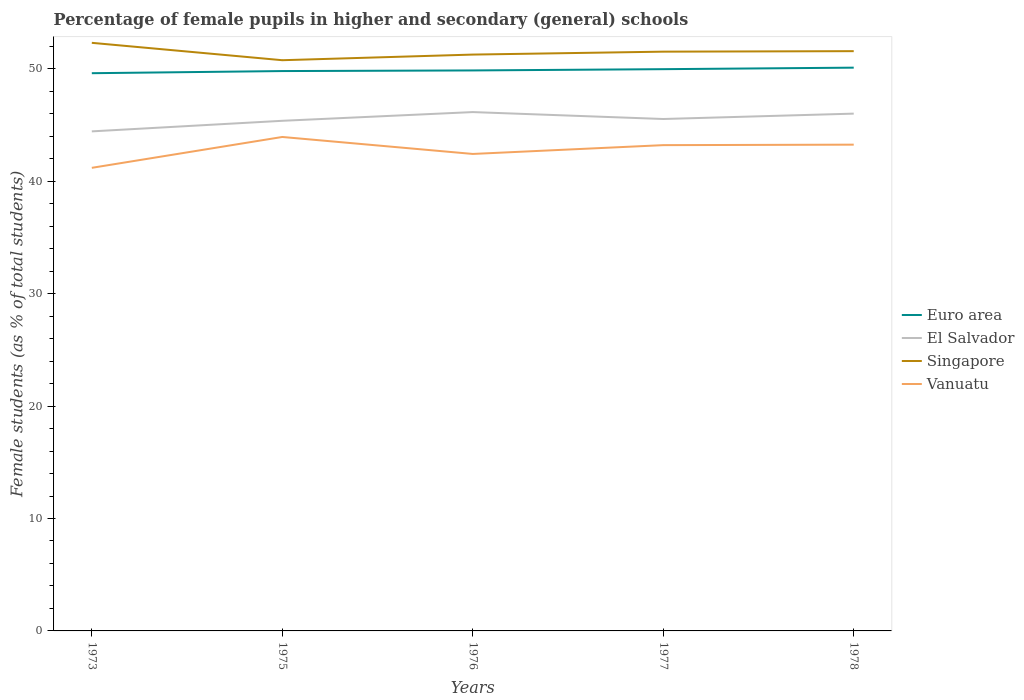How many different coloured lines are there?
Offer a terse response. 4. Does the line corresponding to Euro area intersect with the line corresponding to Vanuatu?
Provide a succinct answer. No. Across all years, what is the maximum percentage of female pupils in higher and secondary schools in Singapore?
Offer a very short reply. 50.77. In which year was the percentage of female pupils in higher and secondary schools in Singapore maximum?
Keep it short and to the point. 1975. What is the total percentage of female pupils in higher and secondary schools in El Salvador in the graph?
Your response must be concise. -0.48. What is the difference between the highest and the second highest percentage of female pupils in higher and secondary schools in Singapore?
Keep it short and to the point. 1.55. What is the difference between the highest and the lowest percentage of female pupils in higher and secondary schools in El Salvador?
Your answer should be compact. 3. Is the percentage of female pupils in higher and secondary schools in Singapore strictly greater than the percentage of female pupils in higher and secondary schools in Euro area over the years?
Keep it short and to the point. No. Are the values on the major ticks of Y-axis written in scientific E-notation?
Make the answer very short. No. Where does the legend appear in the graph?
Keep it short and to the point. Center right. How are the legend labels stacked?
Make the answer very short. Vertical. What is the title of the graph?
Ensure brevity in your answer.  Percentage of female pupils in higher and secondary (general) schools. Does "Aruba" appear as one of the legend labels in the graph?
Your response must be concise. No. What is the label or title of the Y-axis?
Your answer should be very brief. Female students (as % of total students). What is the Female students (as % of total students) in Euro area in 1973?
Offer a terse response. 49.62. What is the Female students (as % of total students) of El Salvador in 1973?
Provide a succinct answer. 44.44. What is the Female students (as % of total students) of Singapore in 1973?
Ensure brevity in your answer.  52.32. What is the Female students (as % of total students) in Vanuatu in 1973?
Provide a short and direct response. 41.2. What is the Female students (as % of total students) in Euro area in 1975?
Offer a very short reply. 49.81. What is the Female students (as % of total students) in El Salvador in 1975?
Provide a short and direct response. 45.38. What is the Female students (as % of total students) in Singapore in 1975?
Your response must be concise. 50.77. What is the Female students (as % of total students) in Vanuatu in 1975?
Ensure brevity in your answer.  43.94. What is the Female students (as % of total students) in Euro area in 1976?
Your response must be concise. 49.86. What is the Female students (as % of total students) in El Salvador in 1976?
Your answer should be compact. 46.16. What is the Female students (as % of total students) in Singapore in 1976?
Offer a terse response. 51.27. What is the Female students (as % of total students) of Vanuatu in 1976?
Your response must be concise. 42.43. What is the Female students (as % of total students) of Euro area in 1977?
Offer a terse response. 49.97. What is the Female students (as % of total students) of El Salvador in 1977?
Make the answer very short. 45.54. What is the Female students (as % of total students) of Singapore in 1977?
Make the answer very short. 51.53. What is the Female students (as % of total students) of Vanuatu in 1977?
Ensure brevity in your answer.  43.22. What is the Female students (as % of total students) of Euro area in 1978?
Give a very brief answer. 50.11. What is the Female students (as % of total students) in El Salvador in 1978?
Provide a short and direct response. 46.02. What is the Female students (as % of total students) in Singapore in 1978?
Provide a succinct answer. 51.58. What is the Female students (as % of total students) of Vanuatu in 1978?
Offer a very short reply. 43.26. Across all years, what is the maximum Female students (as % of total students) of Euro area?
Provide a short and direct response. 50.11. Across all years, what is the maximum Female students (as % of total students) of El Salvador?
Keep it short and to the point. 46.16. Across all years, what is the maximum Female students (as % of total students) in Singapore?
Provide a short and direct response. 52.32. Across all years, what is the maximum Female students (as % of total students) of Vanuatu?
Provide a succinct answer. 43.94. Across all years, what is the minimum Female students (as % of total students) of Euro area?
Keep it short and to the point. 49.62. Across all years, what is the minimum Female students (as % of total students) of El Salvador?
Keep it short and to the point. 44.44. Across all years, what is the minimum Female students (as % of total students) in Singapore?
Offer a terse response. 50.77. Across all years, what is the minimum Female students (as % of total students) of Vanuatu?
Offer a very short reply. 41.2. What is the total Female students (as % of total students) in Euro area in the graph?
Keep it short and to the point. 249.37. What is the total Female students (as % of total students) in El Salvador in the graph?
Your response must be concise. 227.54. What is the total Female students (as % of total students) of Singapore in the graph?
Provide a succinct answer. 257.47. What is the total Female students (as % of total students) in Vanuatu in the graph?
Your response must be concise. 214.05. What is the difference between the Female students (as % of total students) of Euro area in 1973 and that in 1975?
Provide a short and direct response. -0.19. What is the difference between the Female students (as % of total students) in El Salvador in 1973 and that in 1975?
Your response must be concise. -0.94. What is the difference between the Female students (as % of total students) of Singapore in 1973 and that in 1975?
Make the answer very short. 1.55. What is the difference between the Female students (as % of total students) in Vanuatu in 1973 and that in 1975?
Keep it short and to the point. -2.75. What is the difference between the Female students (as % of total students) in Euro area in 1973 and that in 1976?
Ensure brevity in your answer.  -0.25. What is the difference between the Female students (as % of total students) of El Salvador in 1973 and that in 1976?
Offer a very short reply. -1.72. What is the difference between the Female students (as % of total students) in Singapore in 1973 and that in 1976?
Your answer should be very brief. 1.05. What is the difference between the Female students (as % of total students) of Vanuatu in 1973 and that in 1976?
Your answer should be very brief. -1.23. What is the difference between the Female students (as % of total students) in Euro area in 1973 and that in 1977?
Your answer should be compact. -0.36. What is the difference between the Female students (as % of total students) of El Salvador in 1973 and that in 1977?
Provide a short and direct response. -1.1. What is the difference between the Female students (as % of total students) in Singapore in 1973 and that in 1977?
Offer a very short reply. 0.79. What is the difference between the Female students (as % of total students) in Vanuatu in 1973 and that in 1977?
Your answer should be compact. -2.02. What is the difference between the Female students (as % of total students) of Euro area in 1973 and that in 1978?
Give a very brief answer. -0.49. What is the difference between the Female students (as % of total students) of El Salvador in 1973 and that in 1978?
Offer a terse response. -1.58. What is the difference between the Female students (as % of total students) in Singapore in 1973 and that in 1978?
Your response must be concise. 0.74. What is the difference between the Female students (as % of total students) in Vanuatu in 1973 and that in 1978?
Your answer should be compact. -2.06. What is the difference between the Female students (as % of total students) in Euro area in 1975 and that in 1976?
Keep it short and to the point. -0.05. What is the difference between the Female students (as % of total students) of El Salvador in 1975 and that in 1976?
Your answer should be very brief. -0.78. What is the difference between the Female students (as % of total students) of Singapore in 1975 and that in 1976?
Your answer should be very brief. -0.5. What is the difference between the Female students (as % of total students) of Vanuatu in 1975 and that in 1976?
Give a very brief answer. 1.51. What is the difference between the Female students (as % of total students) in Euro area in 1975 and that in 1977?
Offer a terse response. -0.17. What is the difference between the Female students (as % of total students) of El Salvador in 1975 and that in 1977?
Make the answer very short. -0.16. What is the difference between the Female students (as % of total students) in Singapore in 1975 and that in 1977?
Make the answer very short. -0.76. What is the difference between the Female students (as % of total students) of Vanuatu in 1975 and that in 1977?
Make the answer very short. 0.73. What is the difference between the Female students (as % of total students) in Euro area in 1975 and that in 1978?
Give a very brief answer. -0.3. What is the difference between the Female students (as % of total students) of El Salvador in 1975 and that in 1978?
Provide a short and direct response. -0.64. What is the difference between the Female students (as % of total students) of Singapore in 1975 and that in 1978?
Keep it short and to the point. -0.81. What is the difference between the Female students (as % of total students) in Vanuatu in 1975 and that in 1978?
Offer a very short reply. 0.68. What is the difference between the Female students (as % of total students) of Euro area in 1976 and that in 1977?
Keep it short and to the point. -0.11. What is the difference between the Female students (as % of total students) of El Salvador in 1976 and that in 1977?
Ensure brevity in your answer.  0.62. What is the difference between the Female students (as % of total students) of Singapore in 1976 and that in 1977?
Your answer should be compact. -0.26. What is the difference between the Female students (as % of total students) in Vanuatu in 1976 and that in 1977?
Your response must be concise. -0.78. What is the difference between the Female students (as % of total students) in Euro area in 1976 and that in 1978?
Ensure brevity in your answer.  -0.25. What is the difference between the Female students (as % of total students) of El Salvador in 1976 and that in 1978?
Offer a terse response. 0.14. What is the difference between the Female students (as % of total students) in Singapore in 1976 and that in 1978?
Your answer should be very brief. -0.3. What is the difference between the Female students (as % of total students) in Vanuatu in 1976 and that in 1978?
Offer a terse response. -0.83. What is the difference between the Female students (as % of total students) in Euro area in 1977 and that in 1978?
Offer a terse response. -0.13. What is the difference between the Female students (as % of total students) in El Salvador in 1977 and that in 1978?
Give a very brief answer. -0.48. What is the difference between the Female students (as % of total students) in Singapore in 1977 and that in 1978?
Your answer should be very brief. -0.04. What is the difference between the Female students (as % of total students) in Vanuatu in 1977 and that in 1978?
Provide a short and direct response. -0.04. What is the difference between the Female students (as % of total students) in Euro area in 1973 and the Female students (as % of total students) in El Salvador in 1975?
Your response must be concise. 4.23. What is the difference between the Female students (as % of total students) in Euro area in 1973 and the Female students (as % of total students) in Singapore in 1975?
Ensure brevity in your answer.  -1.16. What is the difference between the Female students (as % of total students) of Euro area in 1973 and the Female students (as % of total students) of Vanuatu in 1975?
Your answer should be compact. 5.67. What is the difference between the Female students (as % of total students) in El Salvador in 1973 and the Female students (as % of total students) in Singapore in 1975?
Your response must be concise. -6.33. What is the difference between the Female students (as % of total students) of El Salvador in 1973 and the Female students (as % of total students) of Vanuatu in 1975?
Offer a very short reply. 0.5. What is the difference between the Female students (as % of total students) in Singapore in 1973 and the Female students (as % of total students) in Vanuatu in 1975?
Provide a succinct answer. 8.37. What is the difference between the Female students (as % of total students) in Euro area in 1973 and the Female students (as % of total students) in El Salvador in 1976?
Your response must be concise. 3.46. What is the difference between the Female students (as % of total students) of Euro area in 1973 and the Female students (as % of total students) of Singapore in 1976?
Your answer should be very brief. -1.66. What is the difference between the Female students (as % of total students) in Euro area in 1973 and the Female students (as % of total students) in Vanuatu in 1976?
Your answer should be very brief. 7.18. What is the difference between the Female students (as % of total students) in El Salvador in 1973 and the Female students (as % of total students) in Singapore in 1976?
Offer a terse response. -6.83. What is the difference between the Female students (as % of total students) in El Salvador in 1973 and the Female students (as % of total students) in Vanuatu in 1976?
Offer a very short reply. 2.01. What is the difference between the Female students (as % of total students) of Singapore in 1973 and the Female students (as % of total students) of Vanuatu in 1976?
Offer a terse response. 9.89. What is the difference between the Female students (as % of total students) in Euro area in 1973 and the Female students (as % of total students) in El Salvador in 1977?
Your answer should be compact. 4.07. What is the difference between the Female students (as % of total students) in Euro area in 1973 and the Female students (as % of total students) in Singapore in 1977?
Provide a short and direct response. -1.92. What is the difference between the Female students (as % of total students) of Euro area in 1973 and the Female students (as % of total students) of Vanuatu in 1977?
Your answer should be very brief. 6.4. What is the difference between the Female students (as % of total students) of El Salvador in 1973 and the Female students (as % of total students) of Singapore in 1977?
Ensure brevity in your answer.  -7.09. What is the difference between the Female students (as % of total students) of El Salvador in 1973 and the Female students (as % of total students) of Vanuatu in 1977?
Your answer should be very brief. 1.22. What is the difference between the Female students (as % of total students) in Singapore in 1973 and the Female students (as % of total students) in Vanuatu in 1977?
Give a very brief answer. 9.1. What is the difference between the Female students (as % of total students) of Euro area in 1973 and the Female students (as % of total students) of El Salvador in 1978?
Your answer should be compact. 3.6. What is the difference between the Female students (as % of total students) of Euro area in 1973 and the Female students (as % of total students) of Singapore in 1978?
Provide a succinct answer. -1.96. What is the difference between the Female students (as % of total students) of Euro area in 1973 and the Female students (as % of total students) of Vanuatu in 1978?
Make the answer very short. 6.36. What is the difference between the Female students (as % of total students) of El Salvador in 1973 and the Female students (as % of total students) of Singapore in 1978?
Your answer should be compact. -7.14. What is the difference between the Female students (as % of total students) in El Salvador in 1973 and the Female students (as % of total students) in Vanuatu in 1978?
Your answer should be compact. 1.18. What is the difference between the Female students (as % of total students) in Singapore in 1973 and the Female students (as % of total students) in Vanuatu in 1978?
Offer a very short reply. 9.06. What is the difference between the Female students (as % of total students) in Euro area in 1975 and the Female students (as % of total students) in El Salvador in 1976?
Make the answer very short. 3.65. What is the difference between the Female students (as % of total students) of Euro area in 1975 and the Female students (as % of total students) of Singapore in 1976?
Keep it short and to the point. -1.47. What is the difference between the Female students (as % of total students) of Euro area in 1975 and the Female students (as % of total students) of Vanuatu in 1976?
Ensure brevity in your answer.  7.37. What is the difference between the Female students (as % of total students) in El Salvador in 1975 and the Female students (as % of total students) in Singapore in 1976?
Your answer should be very brief. -5.89. What is the difference between the Female students (as % of total students) of El Salvador in 1975 and the Female students (as % of total students) of Vanuatu in 1976?
Your answer should be very brief. 2.95. What is the difference between the Female students (as % of total students) in Singapore in 1975 and the Female students (as % of total students) in Vanuatu in 1976?
Offer a very short reply. 8.34. What is the difference between the Female students (as % of total students) in Euro area in 1975 and the Female students (as % of total students) in El Salvador in 1977?
Your answer should be compact. 4.27. What is the difference between the Female students (as % of total students) of Euro area in 1975 and the Female students (as % of total students) of Singapore in 1977?
Offer a terse response. -1.73. What is the difference between the Female students (as % of total students) of Euro area in 1975 and the Female students (as % of total students) of Vanuatu in 1977?
Offer a terse response. 6.59. What is the difference between the Female students (as % of total students) in El Salvador in 1975 and the Female students (as % of total students) in Singapore in 1977?
Your answer should be compact. -6.15. What is the difference between the Female students (as % of total students) of El Salvador in 1975 and the Female students (as % of total students) of Vanuatu in 1977?
Your answer should be compact. 2.16. What is the difference between the Female students (as % of total students) of Singapore in 1975 and the Female students (as % of total students) of Vanuatu in 1977?
Your response must be concise. 7.56. What is the difference between the Female students (as % of total students) of Euro area in 1975 and the Female students (as % of total students) of El Salvador in 1978?
Make the answer very short. 3.79. What is the difference between the Female students (as % of total students) in Euro area in 1975 and the Female students (as % of total students) in Singapore in 1978?
Your answer should be very brief. -1.77. What is the difference between the Female students (as % of total students) of Euro area in 1975 and the Female students (as % of total students) of Vanuatu in 1978?
Ensure brevity in your answer.  6.55. What is the difference between the Female students (as % of total students) of El Salvador in 1975 and the Female students (as % of total students) of Singapore in 1978?
Your answer should be very brief. -6.2. What is the difference between the Female students (as % of total students) of El Salvador in 1975 and the Female students (as % of total students) of Vanuatu in 1978?
Make the answer very short. 2.12. What is the difference between the Female students (as % of total students) in Singapore in 1975 and the Female students (as % of total students) in Vanuatu in 1978?
Provide a succinct answer. 7.51. What is the difference between the Female students (as % of total students) in Euro area in 1976 and the Female students (as % of total students) in El Salvador in 1977?
Keep it short and to the point. 4.32. What is the difference between the Female students (as % of total students) of Euro area in 1976 and the Female students (as % of total students) of Singapore in 1977?
Give a very brief answer. -1.67. What is the difference between the Female students (as % of total students) of Euro area in 1976 and the Female students (as % of total students) of Vanuatu in 1977?
Your response must be concise. 6.65. What is the difference between the Female students (as % of total students) of El Salvador in 1976 and the Female students (as % of total students) of Singapore in 1977?
Keep it short and to the point. -5.38. What is the difference between the Female students (as % of total students) in El Salvador in 1976 and the Female students (as % of total students) in Vanuatu in 1977?
Offer a terse response. 2.94. What is the difference between the Female students (as % of total students) in Singapore in 1976 and the Female students (as % of total students) in Vanuatu in 1977?
Make the answer very short. 8.06. What is the difference between the Female students (as % of total students) in Euro area in 1976 and the Female students (as % of total students) in El Salvador in 1978?
Provide a succinct answer. 3.84. What is the difference between the Female students (as % of total students) in Euro area in 1976 and the Female students (as % of total students) in Singapore in 1978?
Provide a short and direct response. -1.72. What is the difference between the Female students (as % of total students) in Euro area in 1976 and the Female students (as % of total students) in Vanuatu in 1978?
Make the answer very short. 6.6. What is the difference between the Female students (as % of total students) of El Salvador in 1976 and the Female students (as % of total students) of Singapore in 1978?
Your response must be concise. -5.42. What is the difference between the Female students (as % of total students) of El Salvador in 1976 and the Female students (as % of total students) of Vanuatu in 1978?
Give a very brief answer. 2.9. What is the difference between the Female students (as % of total students) of Singapore in 1976 and the Female students (as % of total students) of Vanuatu in 1978?
Offer a terse response. 8.01. What is the difference between the Female students (as % of total students) in Euro area in 1977 and the Female students (as % of total students) in El Salvador in 1978?
Your answer should be very brief. 3.95. What is the difference between the Female students (as % of total students) in Euro area in 1977 and the Female students (as % of total students) in Singapore in 1978?
Your response must be concise. -1.6. What is the difference between the Female students (as % of total students) in Euro area in 1977 and the Female students (as % of total students) in Vanuatu in 1978?
Keep it short and to the point. 6.72. What is the difference between the Female students (as % of total students) in El Salvador in 1977 and the Female students (as % of total students) in Singapore in 1978?
Offer a terse response. -6.04. What is the difference between the Female students (as % of total students) in El Salvador in 1977 and the Female students (as % of total students) in Vanuatu in 1978?
Ensure brevity in your answer.  2.28. What is the difference between the Female students (as % of total students) in Singapore in 1977 and the Female students (as % of total students) in Vanuatu in 1978?
Provide a succinct answer. 8.27. What is the average Female students (as % of total students) in Euro area per year?
Keep it short and to the point. 49.87. What is the average Female students (as % of total students) of El Salvador per year?
Your response must be concise. 45.51. What is the average Female students (as % of total students) in Singapore per year?
Keep it short and to the point. 51.49. What is the average Female students (as % of total students) in Vanuatu per year?
Your response must be concise. 42.81. In the year 1973, what is the difference between the Female students (as % of total students) of Euro area and Female students (as % of total students) of El Salvador?
Keep it short and to the point. 5.17. In the year 1973, what is the difference between the Female students (as % of total students) in Euro area and Female students (as % of total students) in Singapore?
Give a very brief answer. -2.7. In the year 1973, what is the difference between the Female students (as % of total students) in Euro area and Female students (as % of total students) in Vanuatu?
Make the answer very short. 8.42. In the year 1973, what is the difference between the Female students (as % of total students) of El Salvador and Female students (as % of total students) of Singapore?
Provide a succinct answer. -7.88. In the year 1973, what is the difference between the Female students (as % of total students) in El Salvador and Female students (as % of total students) in Vanuatu?
Make the answer very short. 3.24. In the year 1973, what is the difference between the Female students (as % of total students) of Singapore and Female students (as % of total students) of Vanuatu?
Ensure brevity in your answer.  11.12. In the year 1975, what is the difference between the Female students (as % of total students) in Euro area and Female students (as % of total students) in El Salvador?
Provide a succinct answer. 4.43. In the year 1975, what is the difference between the Female students (as % of total students) in Euro area and Female students (as % of total students) in Singapore?
Make the answer very short. -0.96. In the year 1975, what is the difference between the Female students (as % of total students) of Euro area and Female students (as % of total students) of Vanuatu?
Your response must be concise. 5.86. In the year 1975, what is the difference between the Female students (as % of total students) of El Salvador and Female students (as % of total students) of Singapore?
Provide a succinct answer. -5.39. In the year 1975, what is the difference between the Female students (as % of total students) of El Salvador and Female students (as % of total students) of Vanuatu?
Give a very brief answer. 1.44. In the year 1975, what is the difference between the Female students (as % of total students) in Singapore and Female students (as % of total students) in Vanuatu?
Your response must be concise. 6.83. In the year 1976, what is the difference between the Female students (as % of total students) of Euro area and Female students (as % of total students) of El Salvador?
Offer a very short reply. 3.7. In the year 1976, what is the difference between the Female students (as % of total students) in Euro area and Female students (as % of total students) in Singapore?
Give a very brief answer. -1.41. In the year 1976, what is the difference between the Female students (as % of total students) of Euro area and Female students (as % of total students) of Vanuatu?
Keep it short and to the point. 7.43. In the year 1976, what is the difference between the Female students (as % of total students) in El Salvador and Female students (as % of total students) in Singapore?
Offer a very short reply. -5.12. In the year 1976, what is the difference between the Female students (as % of total students) in El Salvador and Female students (as % of total students) in Vanuatu?
Make the answer very short. 3.72. In the year 1976, what is the difference between the Female students (as % of total students) of Singapore and Female students (as % of total students) of Vanuatu?
Provide a short and direct response. 8.84. In the year 1977, what is the difference between the Female students (as % of total students) in Euro area and Female students (as % of total students) in El Salvador?
Keep it short and to the point. 4.43. In the year 1977, what is the difference between the Female students (as % of total students) of Euro area and Female students (as % of total students) of Singapore?
Your response must be concise. -1.56. In the year 1977, what is the difference between the Female students (as % of total students) of Euro area and Female students (as % of total students) of Vanuatu?
Give a very brief answer. 6.76. In the year 1977, what is the difference between the Female students (as % of total students) of El Salvador and Female students (as % of total students) of Singapore?
Your response must be concise. -5.99. In the year 1977, what is the difference between the Female students (as % of total students) of El Salvador and Female students (as % of total students) of Vanuatu?
Your answer should be compact. 2.32. In the year 1977, what is the difference between the Female students (as % of total students) of Singapore and Female students (as % of total students) of Vanuatu?
Ensure brevity in your answer.  8.32. In the year 1978, what is the difference between the Female students (as % of total students) of Euro area and Female students (as % of total students) of El Salvador?
Offer a terse response. 4.09. In the year 1978, what is the difference between the Female students (as % of total students) of Euro area and Female students (as % of total students) of Singapore?
Offer a terse response. -1.47. In the year 1978, what is the difference between the Female students (as % of total students) in Euro area and Female students (as % of total students) in Vanuatu?
Keep it short and to the point. 6.85. In the year 1978, what is the difference between the Female students (as % of total students) of El Salvador and Female students (as % of total students) of Singapore?
Make the answer very short. -5.56. In the year 1978, what is the difference between the Female students (as % of total students) in El Salvador and Female students (as % of total students) in Vanuatu?
Make the answer very short. 2.76. In the year 1978, what is the difference between the Female students (as % of total students) in Singapore and Female students (as % of total students) in Vanuatu?
Give a very brief answer. 8.32. What is the ratio of the Female students (as % of total students) in El Salvador in 1973 to that in 1975?
Your answer should be compact. 0.98. What is the ratio of the Female students (as % of total students) in Singapore in 1973 to that in 1975?
Give a very brief answer. 1.03. What is the ratio of the Female students (as % of total students) of Vanuatu in 1973 to that in 1975?
Provide a short and direct response. 0.94. What is the ratio of the Female students (as % of total students) of El Salvador in 1973 to that in 1976?
Give a very brief answer. 0.96. What is the ratio of the Female students (as % of total students) in Singapore in 1973 to that in 1976?
Give a very brief answer. 1.02. What is the ratio of the Female students (as % of total students) of Vanuatu in 1973 to that in 1976?
Keep it short and to the point. 0.97. What is the ratio of the Female students (as % of total students) in Euro area in 1973 to that in 1977?
Offer a very short reply. 0.99. What is the ratio of the Female students (as % of total students) of El Salvador in 1973 to that in 1977?
Offer a very short reply. 0.98. What is the ratio of the Female students (as % of total students) in Singapore in 1973 to that in 1977?
Offer a very short reply. 1.02. What is the ratio of the Female students (as % of total students) of Vanuatu in 1973 to that in 1977?
Give a very brief answer. 0.95. What is the ratio of the Female students (as % of total students) in Euro area in 1973 to that in 1978?
Provide a short and direct response. 0.99. What is the ratio of the Female students (as % of total students) in El Salvador in 1973 to that in 1978?
Give a very brief answer. 0.97. What is the ratio of the Female students (as % of total students) of Singapore in 1973 to that in 1978?
Provide a succinct answer. 1.01. What is the ratio of the Female students (as % of total students) in Euro area in 1975 to that in 1976?
Provide a succinct answer. 1. What is the ratio of the Female students (as % of total students) of El Salvador in 1975 to that in 1976?
Provide a succinct answer. 0.98. What is the ratio of the Female students (as % of total students) in Singapore in 1975 to that in 1976?
Offer a very short reply. 0.99. What is the ratio of the Female students (as % of total students) of Vanuatu in 1975 to that in 1976?
Your answer should be very brief. 1.04. What is the ratio of the Female students (as % of total students) in El Salvador in 1975 to that in 1977?
Ensure brevity in your answer.  1. What is the ratio of the Female students (as % of total students) of Singapore in 1975 to that in 1977?
Provide a short and direct response. 0.99. What is the ratio of the Female students (as % of total students) of Vanuatu in 1975 to that in 1977?
Offer a terse response. 1.02. What is the ratio of the Female students (as % of total students) of El Salvador in 1975 to that in 1978?
Your answer should be very brief. 0.99. What is the ratio of the Female students (as % of total students) of Singapore in 1975 to that in 1978?
Your response must be concise. 0.98. What is the ratio of the Female students (as % of total students) in Vanuatu in 1975 to that in 1978?
Give a very brief answer. 1.02. What is the ratio of the Female students (as % of total students) of El Salvador in 1976 to that in 1977?
Provide a short and direct response. 1.01. What is the ratio of the Female students (as % of total students) of Vanuatu in 1976 to that in 1977?
Your response must be concise. 0.98. What is the ratio of the Female students (as % of total students) of El Salvador in 1976 to that in 1978?
Provide a short and direct response. 1. What is the ratio of the Female students (as % of total students) of Singapore in 1976 to that in 1978?
Ensure brevity in your answer.  0.99. What is the ratio of the Female students (as % of total students) in Vanuatu in 1976 to that in 1978?
Offer a very short reply. 0.98. What is the ratio of the Female students (as % of total students) of Euro area in 1977 to that in 1978?
Offer a terse response. 1. What is the ratio of the Female students (as % of total students) of El Salvador in 1977 to that in 1978?
Provide a short and direct response. 0.99. What is the difference between the highest and the second highest Female students (as % of total students) of Euro area?
Ensure brevity in your answer.  0.13. What is the difference between the highest and the second highest Female students (as % of total students) in El Salvador?
Your response must be concise. 0.14. What is the difference between the highest and the second highest Female students (as % of total students) of Singapore?
Your answer should be very brief. 0.74. What is the difference between the highest and the second highest Female students (as % of total students) in Vanuatu?
Provide a short and direct response. 0.68. What is the difference between the highest and the lowest Female students (as % of total students) of Euro area?
Provide a succinct answer. 0.49. What is the difference between the highest and the lowest Female students (as % of total students) of El Salvador?
Ensure brevity in your answer.  1.72. What is the difference between the highest and the lowest Female students (as % of total students) of Singapore?
Your answer should be compact. 1.55. What is the difference between the highest and the lowest Female students (as % of total students) of Vanuatu?
Ensure brevity in your answer.  2.75. 